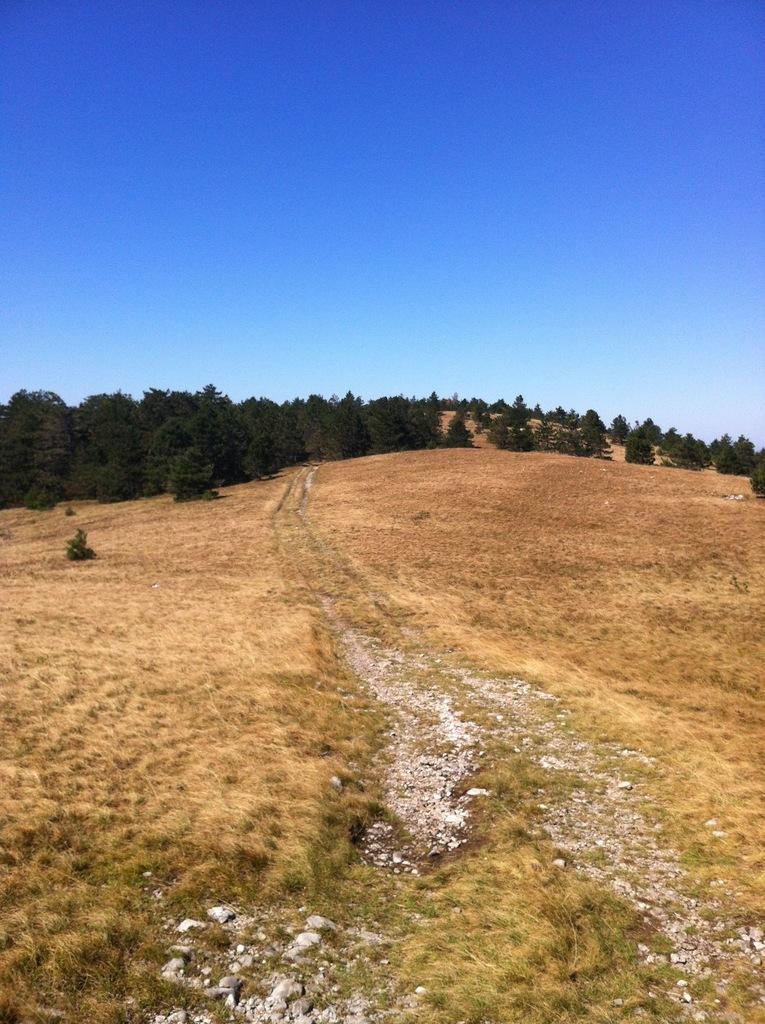What type of vegetation can be seen in the image? There are trees in the image. What color are the trees? The trees are green in color. What color is the sky in the background of the image? The background sky is blue in color. What type of brush can be seen in the image? There is no brush present in the image. What room is depicted in the image? The image does not depict a room; it features trees and a blue sky. 